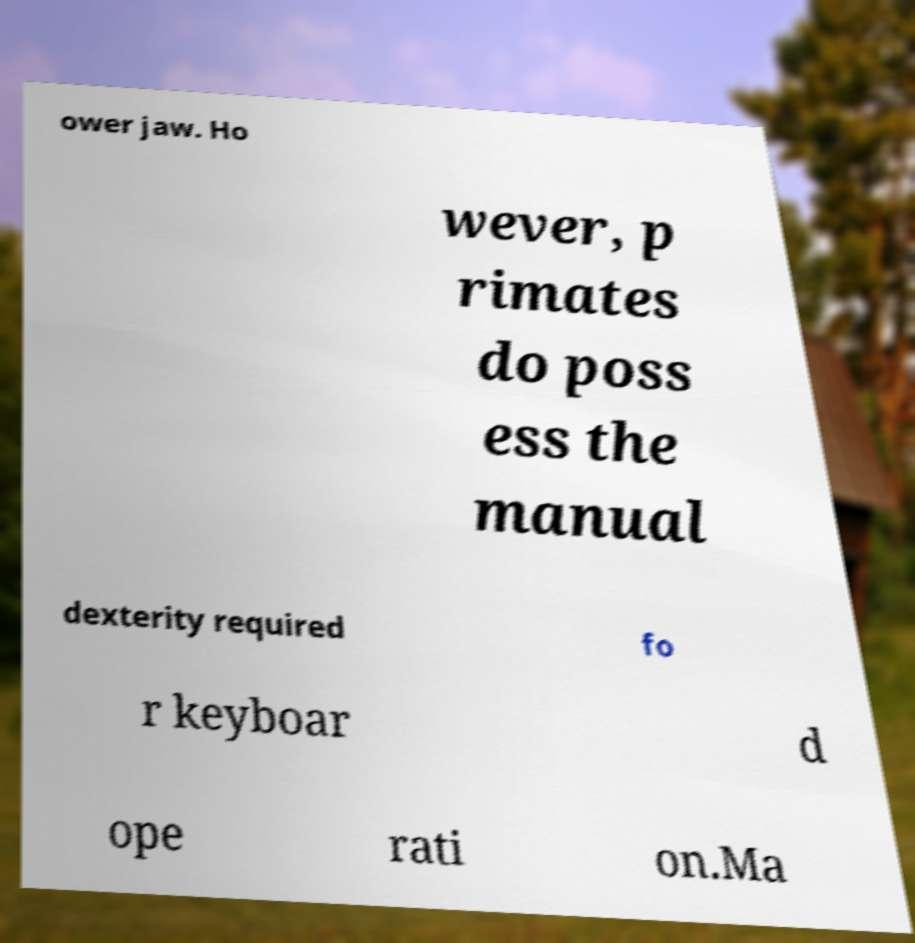I need the written content from this picture converted into text. Can you do that? ower jaw. Ho wever, p rimates do poss ess the manual dexterity required fo r keyboar d ope rati on.Ma 